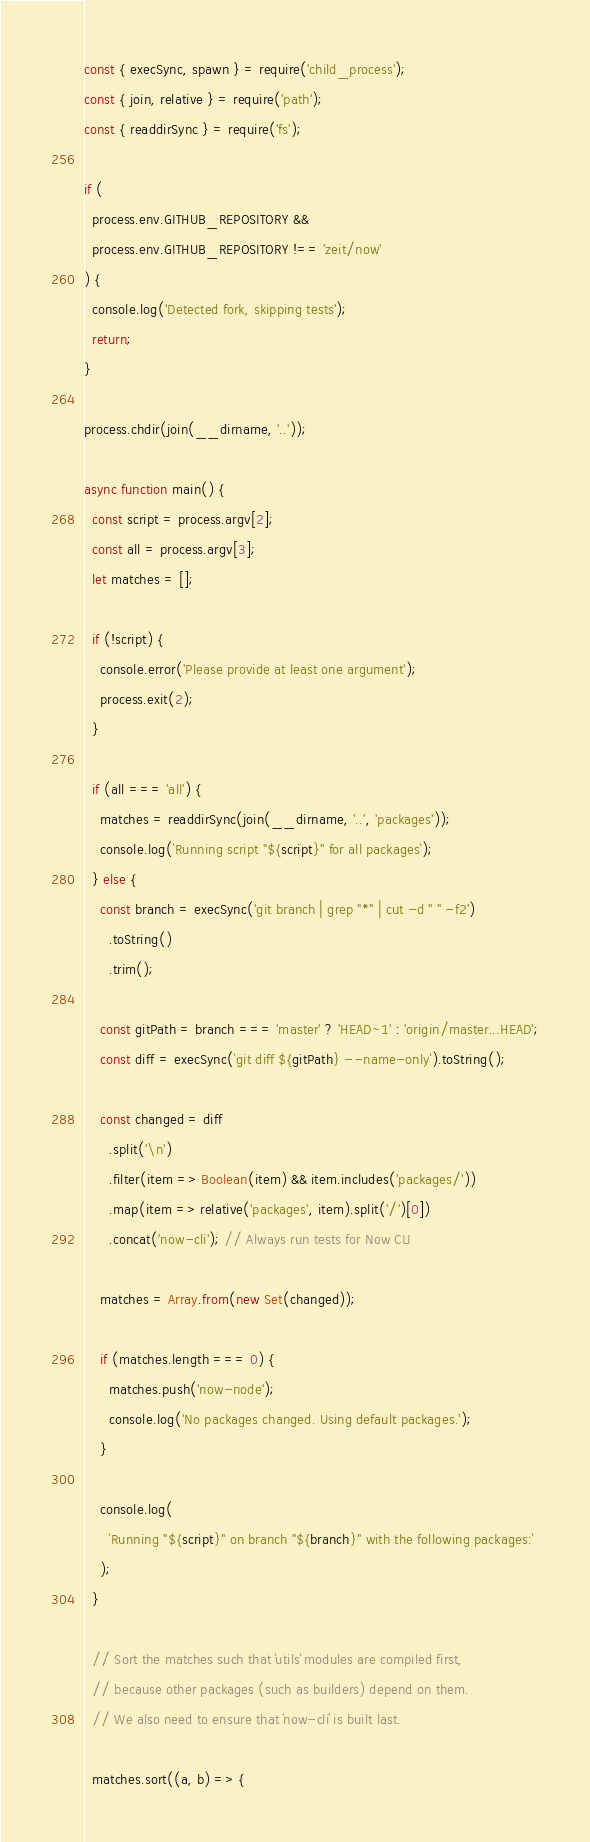Convert code to text. <code><loc_0><loc_0><loc_500><loc_500><_JavaScript_>const { execSync, spawn } = require('child_process');
const { join, relative } = require('path');
const { readdirSync } = require('fs');

if (
  process.env.GITHUB_REPOSITORY &&
  process.env.GITHUB_REPOSITORY !== 'zeit/now'
) {
  console.log('Detected fork, skipping tests');
  return;
}

process.chdir(join(__dirname, '..'));

async function main() {
  const script = process.argv[2];
  const all = process.argv[3];
  let matches = [];

  if (!script) {
    console.error('Please provide at least one argument');
    process.exit(2);
  }

  if (all === 'all') {
    matches = readdirSync(join(__dirname, '..', 'packages'));
    console.log(`Running script "${script}" for all packages`);
  } else {
    const branch = execSync('git branch | grep "*" | cut -d " " -f2')
      .toString()
      .trim();

    const gitPath = branch === 'master' ? 'HEAD~1' : 'origin/master...HEAD';
    const diff = execSync(`git diff ${gitPath} --name-only`).toString();

    const changed = diff
      .split('\n')
      .filter(item => Boolean(item) && item.includes('packages/'))
      .map(item => relative('packages', item).split('/')[0])
      .concat('now-cli'); // Always run tests for Now CLI

    matches = Array.from(new Set(changed));

    if (matches.length === 0) {
      matches.push('now-node');
      console.log('No packages changed. Using default packages.');
    }

    console.log(
      `Running "${script}" on branch "${branch}" with the following packages:`
    );
  }

  // Sort the matches such that `utils` modules are compiled first,
  // because other packages (such as builders) depend on them.
  // We also need to ensure that `now-cli` is built last.

  matches.sort((a, b) => {</code> 